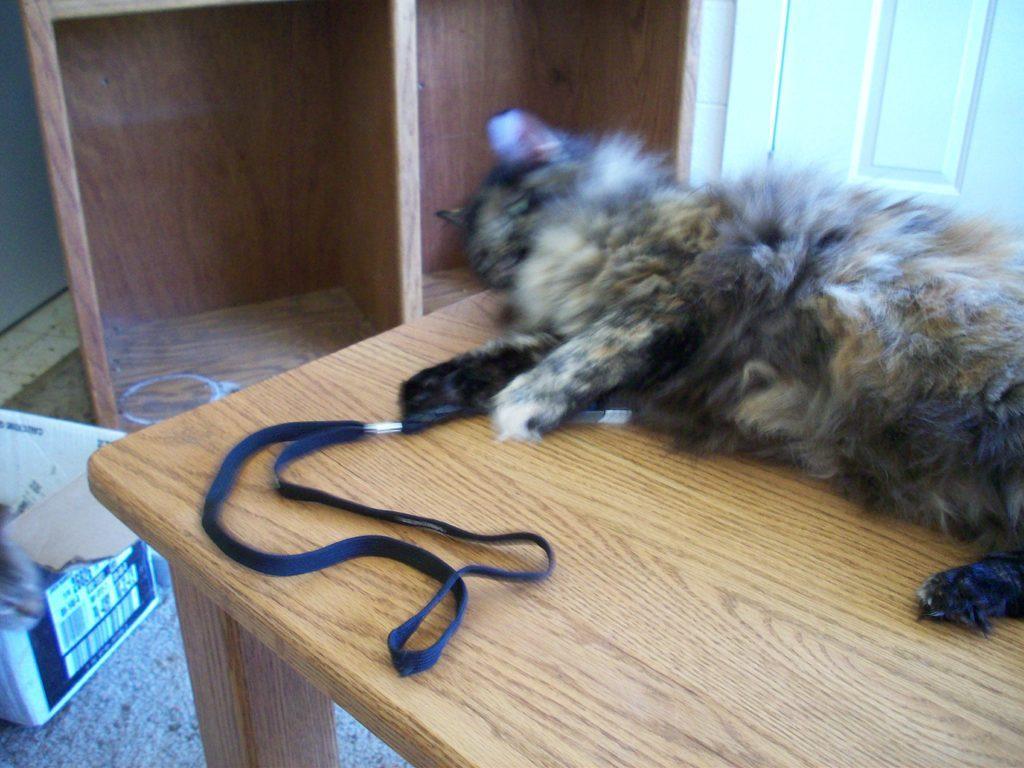How would you summarize this image in a sentence or two? In this picture I can see a cat lying on the table, side there is a wooden shelves and also I can see a box placed on the carpet. 